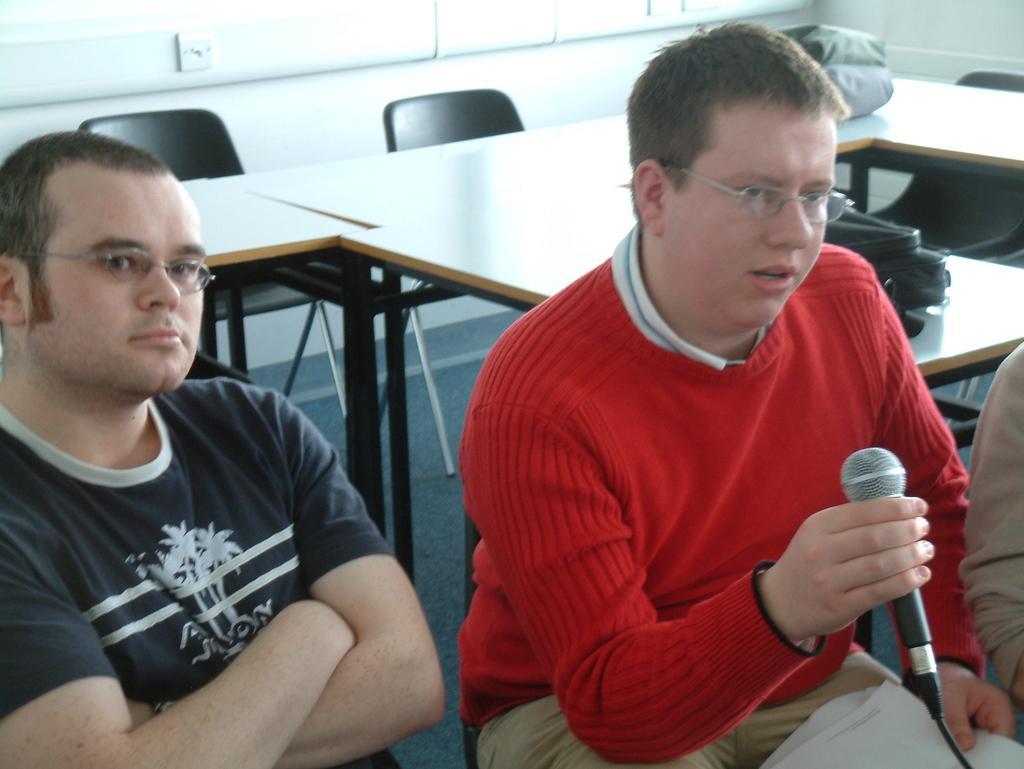Please provide a concise description of this image. In the image we can see two men sitting, wearing clothes and spectacles and one man is holding a microphone in his hand. There are many chairs and tables, on the table, we can see the bags. Here we can see the floor and it looks like there is another person on the right side of the image. 